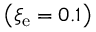<formula> <loc_0><loc_0><loc_500><loc_500>\left ( \xi _ { e } = 0 . 1 \right )</formula> 